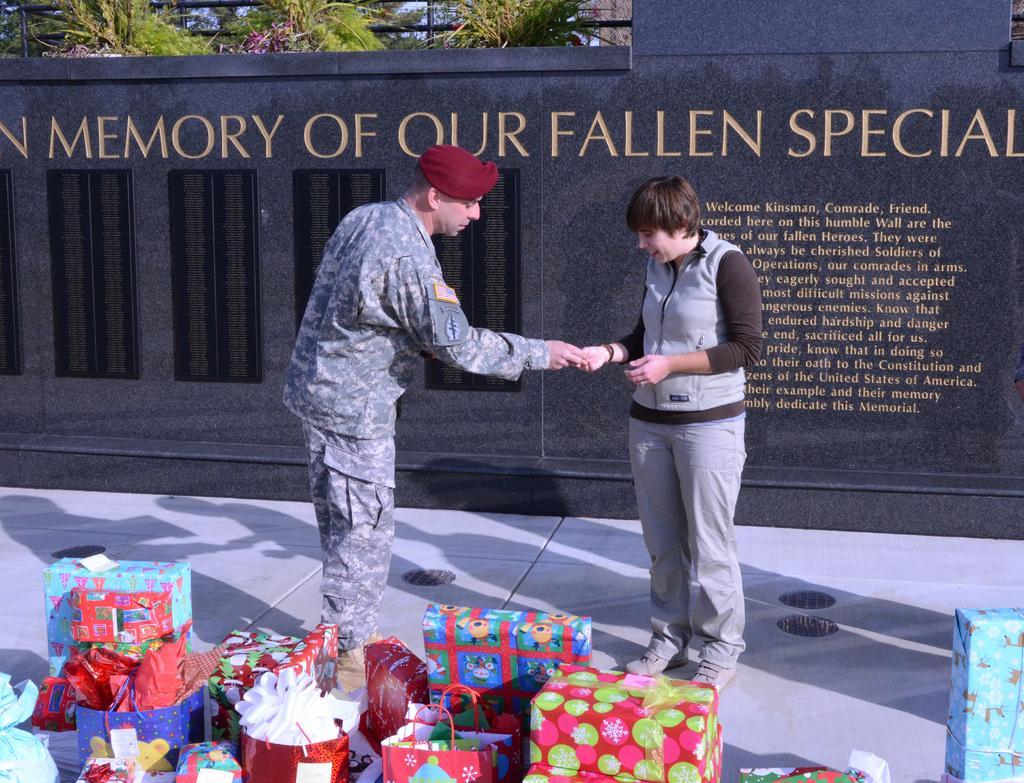How would you summarize this image in a sentence or two? In this picture there is a man who is wearing army uniform. Besides him there is a woman who is wearing jacket, trouser and shoes. At the bottom I can see the boxes, bags and other objects. In the back I can see the windows on the wall. At the top I can see many trees and sky. 